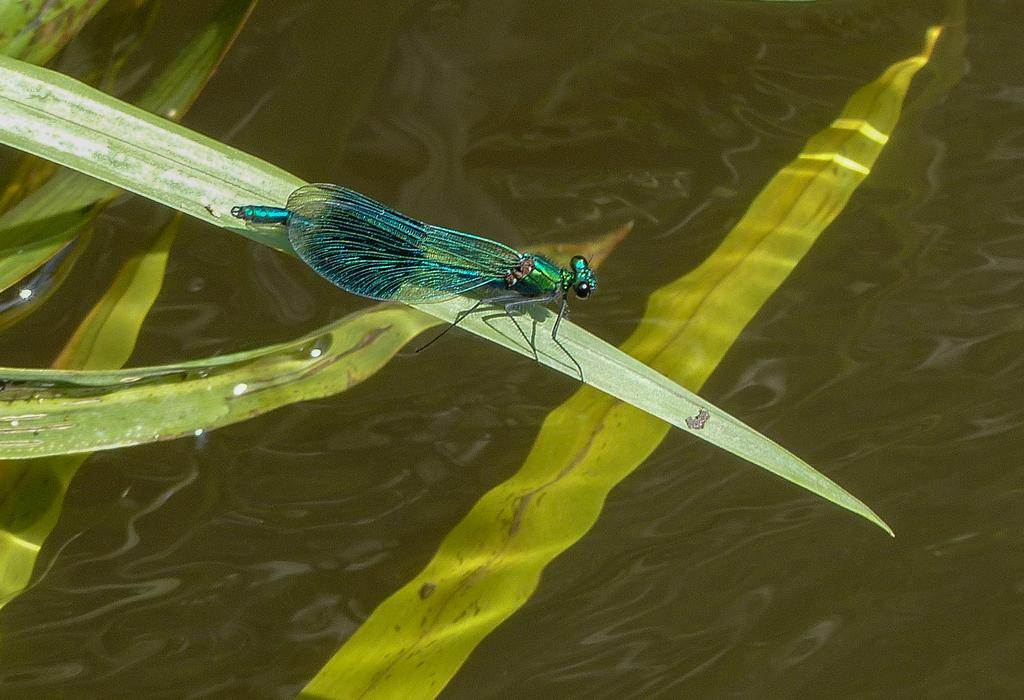What is on the leaf in the image? There is an insect on a leaf in the image. What can be seen at the bottom of the image? There is water visible at the bottom of the image. How many goats are present in the image? There are no goats present in the image; it features an insect on a leaf and water at the bottom. 